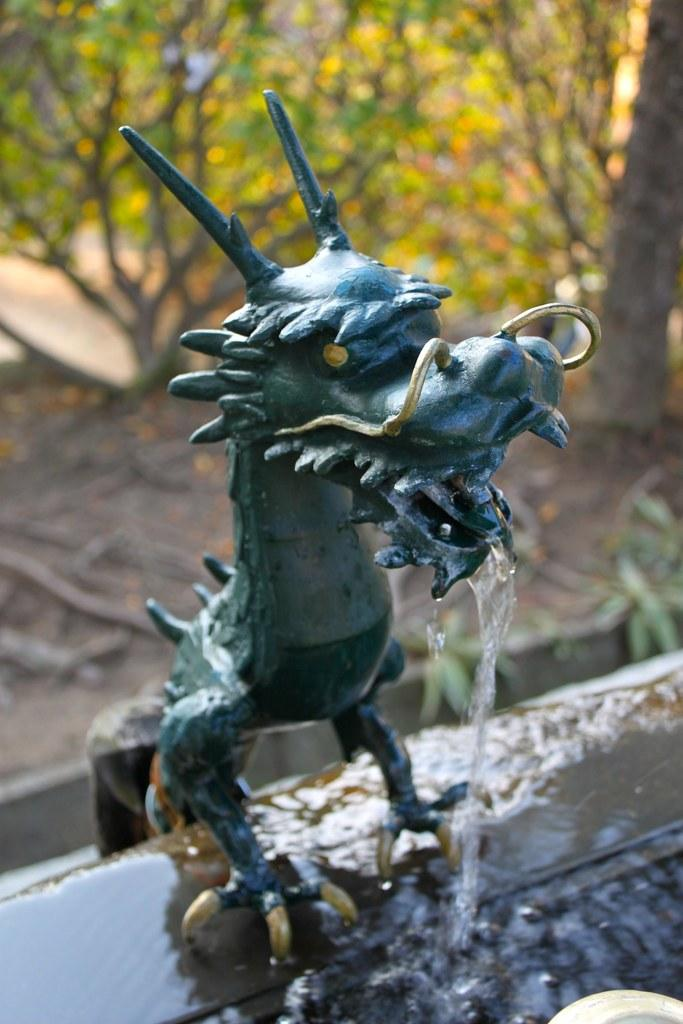What is the main subject in the image? There is a statue in the image. What else can be seen in the image besides the statue? Water and trees are visible in the image. How is the background of the image depicted? The background of the image is blurred. How many chairs are present in the image? There are no chairs visible in the image. What part of the statue represents its historical significance? The image does not provide information about the historical significance of the statue, so it is not possible to answer this question. 